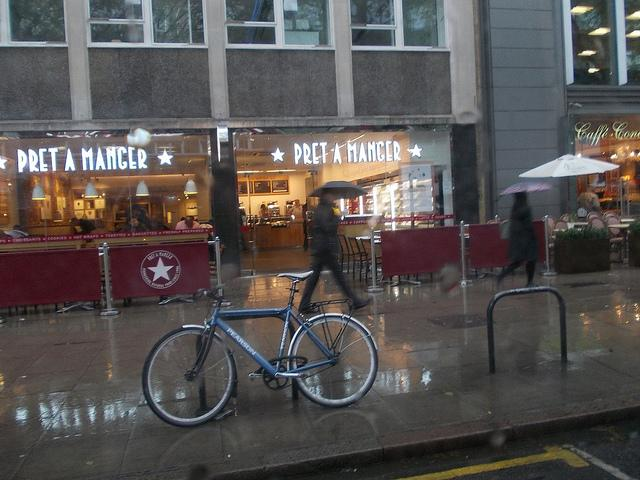What time of day is it here? Please explain your reasoning. twilight. The day is twilight. 